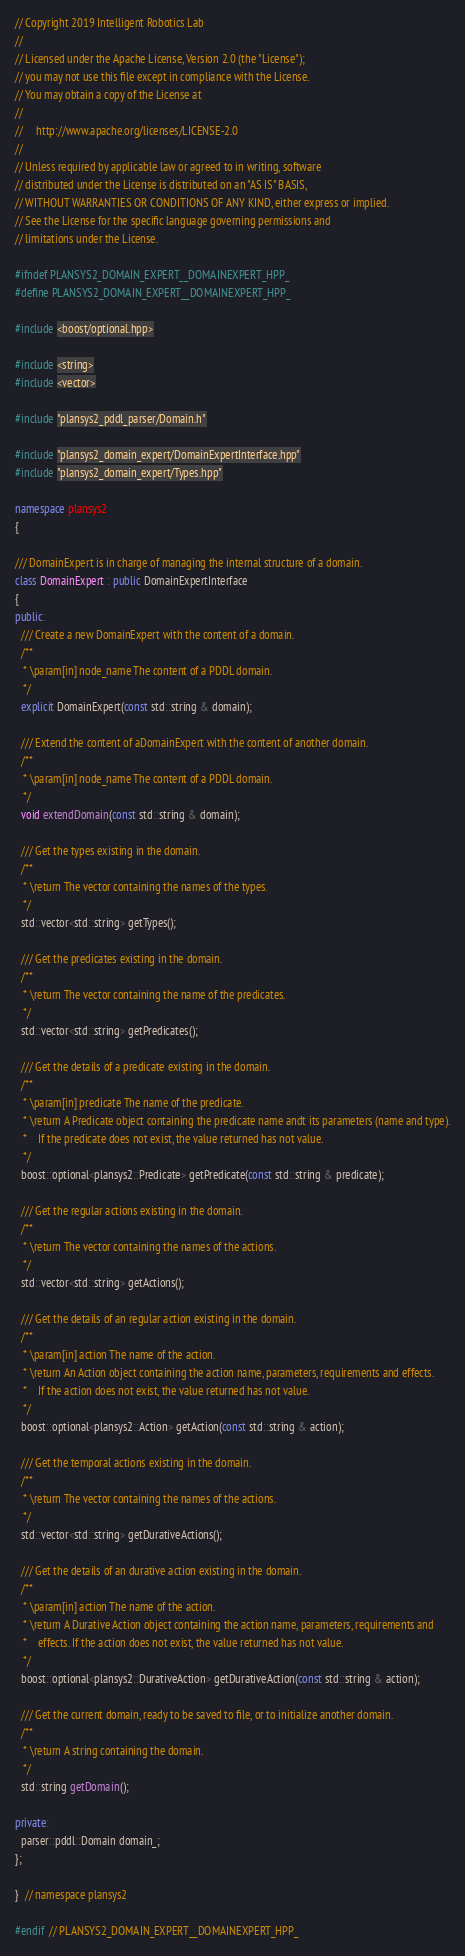<code> <loc_0><loc_0><loc_500><loc_500><_C++_>// Copyright 2019 Intelligent Robotics Lab
//
// Licensed under the Apache License, Version 2.0 (the "License");
// you may not use this file except in compliance with the License.
// You may obtain a copy of the License at
//
//     http://www.apache.org/licenses/LICENSE-2.0
//
// Unless required by applicable law or agreed to in writing, software
// distributed under the License is distributed on an "AS IS" BASIS,
// WITHOUT WARRANTIES OR CONDITIONS OF ANY KIND, either express or implied.
// See the License for the specific language governing permissions and
// limitations under the License.

#ifndef PLANSYS2_DOMAIN_EXPERT__DOMAINEXPERT_HPP_
#define PLANSYS2_DOMAIN_EXPERT__DOMAINEXPERT_HPP_

#include <boost/optional.hpp>

#include <string>
#include <vector>

#include "plansys2_pddl_parser/Domain.h"

#include "plansys2_domain_expert/DomainExpertInterface.hpp"
#include "plansys2_domain_expert/Types.hpp"

namespace plansys2
{

/// DomainExpert is in charge of managing the internal structure of a domain.
class DomainExpert : public DomainExpertInterface
{
public:
  /// Create a new DomainExpert with the content of a domain.
  /**
   * \param[in] node_name The content of a PDDL domain.
   */
  explicit DomainExpert(const std::string & domain);

  /// Extend the content of aDomainExpert with the content of another domain.
  /**
   * \param[in] node_name The content of a PDDL domain.
   */
  void extendDomain(const std::string & domain);

  /// Get the types existing in the domain.
  /**
   * \return The vector containing the names of the types.
   */
  std::vector<std::string> getTypes();

  /// Get the predicates existing in the domain.
  /**
   * \return The vector containing the name of the predicates.
   */
  std::vector<std::string> getPredicates();

  /// Get the details of a predicate existing in the domain.
  /**
   * \param[in] predicate The name of the predicate.
   * \return A Predicate object containing the predicate name andt its parameters (name and type).
   *    If the predicate does not exist, the value returned has not value.
   */
  boost::optional<plansys2::Predicate> getPredicate(const std::string & predicate);

  /// Get the regular actions existing in the domain.
  /**
   * \return The vector containing the names of the actions.
   */
  std::vector<std::string> getActions();

  /// Get the details of an regular action existing in the domain.
  /**
   * \param[in] action The name of the action.
   * \return An Action object containing the action name, parameters, requirements and effects.
   *    If the action does not exist, the value returned has not value.
   */
  boost::optional<plansys2::Action> getAction(const std::string & action);

  /// Get the temporal actions existing in the domain.
  /**
   * \return The vector containing the names of the actions.
   */
  std::vector<std::string> getDurativeActions();

  /// Get the details of an durative action existing in the domain.
  /**
   * \param[in] action The name of the action.
   * \return A Durative Action object containing the action name, parameters, requirements and
   *    effects. If the action does not exist, the value returned has not value.
   */
  boost::optional<plansys2::DurativeAction> getDurativeAction(const std::string & action);

  /// Get the current domain, ready to be saved to file, or to initialize another domain.
  /**
   * \return A string containing the domain.
   */
  std::string getDomain();

private:
  parser::pddl::Domain domain_;
};

}  // namespace plansys2

#endif  // PLANSYS2_DOMAIN_EXPERT__DOMAINEXPERT_HPP_
</code> 